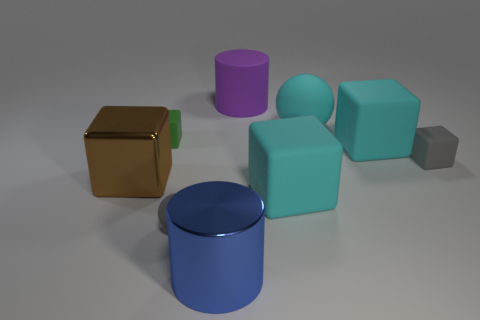Subtract 2 blocks. How many blocks are left? 3 Subtract all gray cubes. How many cubes are left? 4 Subtract all brown cubes. How many cubes are left? 4 Subtract all purple cubes. Subtract all red spheres. How many cubes are left? 5 Add 1 cyan metal things. How many objects exist? 10 Subtract all spheres. How many objects are left? 7 Add 3 blue metal things. How many blue metal things exist? 4 Subtract 1 gray spheres. How many objects are left? 8 Subtract all small gray balls. Subtract all purple rubber cylinders. How many objects are left? 7 Add 7 gray rubber things. How many gray rubber things are left? 9 